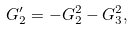<formula> <loc_0><loc_0><loc_500><loc_500>G _ { 2 } ^ { \prime } = - G _ { 2 } ^ { 2 } - G _ { 3 } ^ { 2 } ,</formula> 